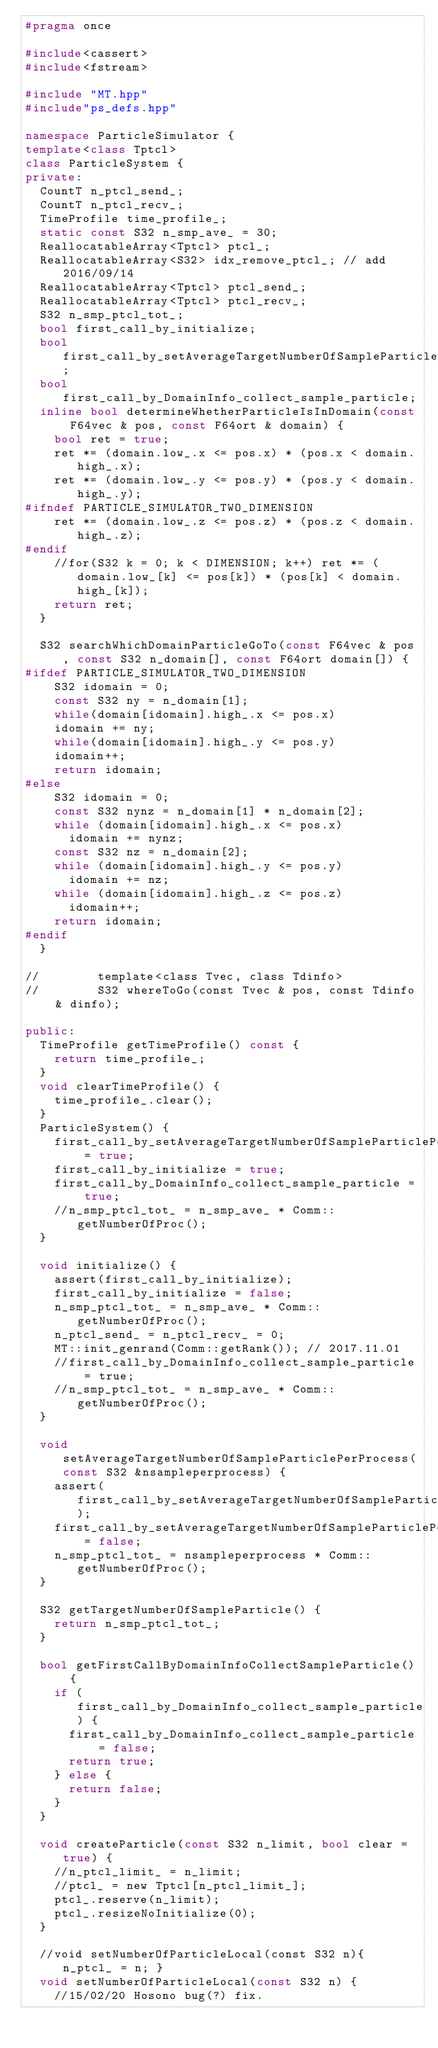<code> <loc_0><loc_0><loc_500><loc_500><_C++_>#pragma once

#include<cassert>
#include<fstream>

#include "MT.hpp"
#include"ps_defs.hpp"

namespace ParticleSimulator {
template<class Tptcl>
class ParticleSystem {
private:
	CountT n_ptcl_send_;
	CountT n_ptcl_recv_;
	TimeProfile time_profile_;
	static const S32 n_smp_ave_ = 30;
	ReallocatableArray<Tptcl> ptcl_;
	ReallocatableArray<S32> idx_remove_ptcl_; // add 2016/09/14
	ReallocatableArray<Tptcl> ptcl_send_;
	ReallocatableArray<Tptcl> ptcl_recv_;
	S32 n_smp_ptcl_tot_;
	bool first_call_by_initialize;
	bool first_call_by_setAverageTargetNumberOfSampleParticlePerProcess;
	bool first_call_by_DomainInfo_collect_sample_particle;
	inline bool determineWhetherParticleIsInDomain(const F64vec & pos, const F64ort & domain) {
		bool ret = true;
		ret *= (domain.low_.x <= pos.x) * (pos.x < domain.high_.x);
		ret *= (domain.low_.y <= pos.y) * (pos.y < domain.high_.y);
#ifndef PARTICLE_SIMULATOR_TWO_DIMENSION
		ret *= (domain.low_.z <= pos.z) * (pos.z < domain.high_.z);
#endif
		//for(S32 k = 0; k < DIMENSION; k++) ret *= (domain.low_[k] <= pos[k]) * (pos[k] < domain.high_[k]);
		return ret;
	}

	S32 searchWhichDomainParticleGoTo(const F64vec & pos, const S32 n_domain[], const F64ort domain[]) {
#ifdef PARTICLE_SIMULATOR_TWO_DIMENSION
		S32 idomain = 0;
		const S32 ny = n_domain[1];
		while(domain[idomain].high_.x <= pos.x)
		idomain += ny;
		while(domain[idomain].high_.y <= pos.y)
		idomain++;
		return idomain;
#else
		S32 idomain = 0;
		const S32 nynz = n_domain[1] * n_domain[2];
		while (domain[idomain].high_.x <= pos.x)
			idomain += nynz;
		const S32 nz = n_domain[2];
		while (domain[idomain].high_.y <= pos.y)
			idomain += nz;
		while (domain[idomain].high_.z <= pos.z)
			idomain++;
		return idomain;
#endif
	}

//        template<class Tvec, class Tdinfo>
//        S32 whereToGo(const Tvec & pos, const Tdinfo & dinfo);

public:
	TimeProfile getTimeProfile() const {
		return time_profile_;
	}
	void clearTimeProfile() {
		time_profile_.clear();
	}
	ParticleSystem() {
		first_call_by_setAverageTargetNumberOfSampleParticlePerProcess = true;
		first_call_by_initialize = true;
		first_call_by_DomainInfo_collect_sample_particle = true;
		//n_smp_ptcl_tot_ = n_smp_ave_ * Comm::getNumberOfProc();
	}

	void initialize() {
		assert(first_call_by_initialize);
		first_call_by_initialize = false;
		n_smp_ptcl_tot_ = n_smp_ave_ * Comm::getNumberOfProc();
		n_ptcl_send_ = n_ptcl_recv_ = 0;
		MT::init_genrand(Comm::getRank()); // 2017.11.01
		//first_call_by_DomainInfo_collect_sample_particle = true;
		//n_smp_ptcl_tot_ = n_smp_ave_ * Comm::getNumberOfProc();
	}

	void setAverageTargetNumberOfSampleParticlePerProcess(const S32 &nsampleperprocess) {
		assert(first_call_by_setAverageTargetNumberOfSampleParticlePerProcess);
		first_call_by_setAverageTargetNumberOfSampleParticlePerProcess = false;
		n_smp_ptcl_tot_ = nsampleperprocess * Comm::getNumberOfProc();
	}

	S32 getTargetNumberOfSampleParticle() {
		return n_smp_ptcl_tot_;
	}

	bool getFirstCallByDomainInfoCollectSampleParticle() {
		if (first_call_by_DomainInfo_collect_sample_particle) {
			first_call_by_DomainInfo_collect_sample_particle = false;
			return true;
		} else {
			return false;
		}
	}

	void createParticle(const S32 n_limit, bool clear = true) {
		//n_ptcl_limit_ = n_limit;
		//ptcl_ = new Tptcl[n_ptcl_limit_];
		ptcl_.reserve(n_limit);
		ptcl_.resizeNoInitialize(0);
	}

	//void setNumberOfParticleLocal(const S32 n){ n_ptcl_ = n; }
	void setNumberOfParticleLocal(const S32 n) {
		//15/02/20 Hosono bug(?) fix.</code> 